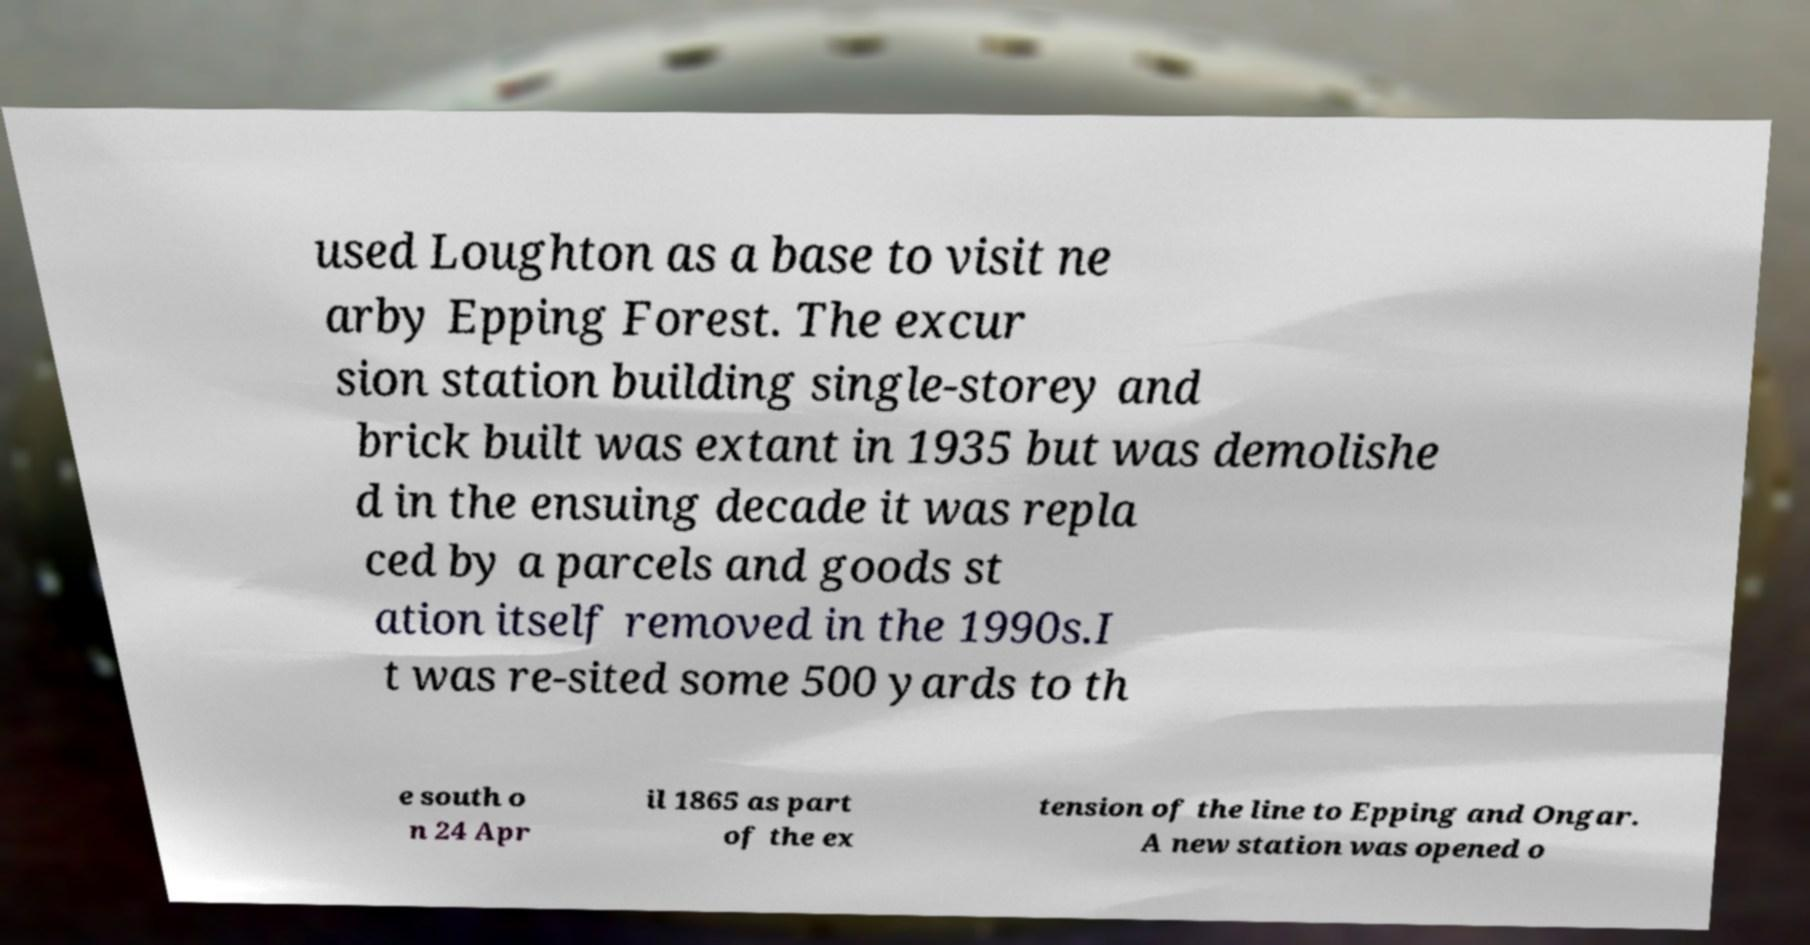There's text embedded in this image that I need extracted. Can you transcribe it verbatim? used Loughton as a base to visit ne arby Epping Forest. The excur sion station building single-storey and brick built was extant in 1935 but was demolishe d in the ensuing decade it was repla ced by a parcels and goods st ation itself removed in the 1990s.I t was re-sited some 500 yards to th e south o n 24 Apr il 1865 as part of the ex tension of the line to Epping and Ongar. A new station was opened o 